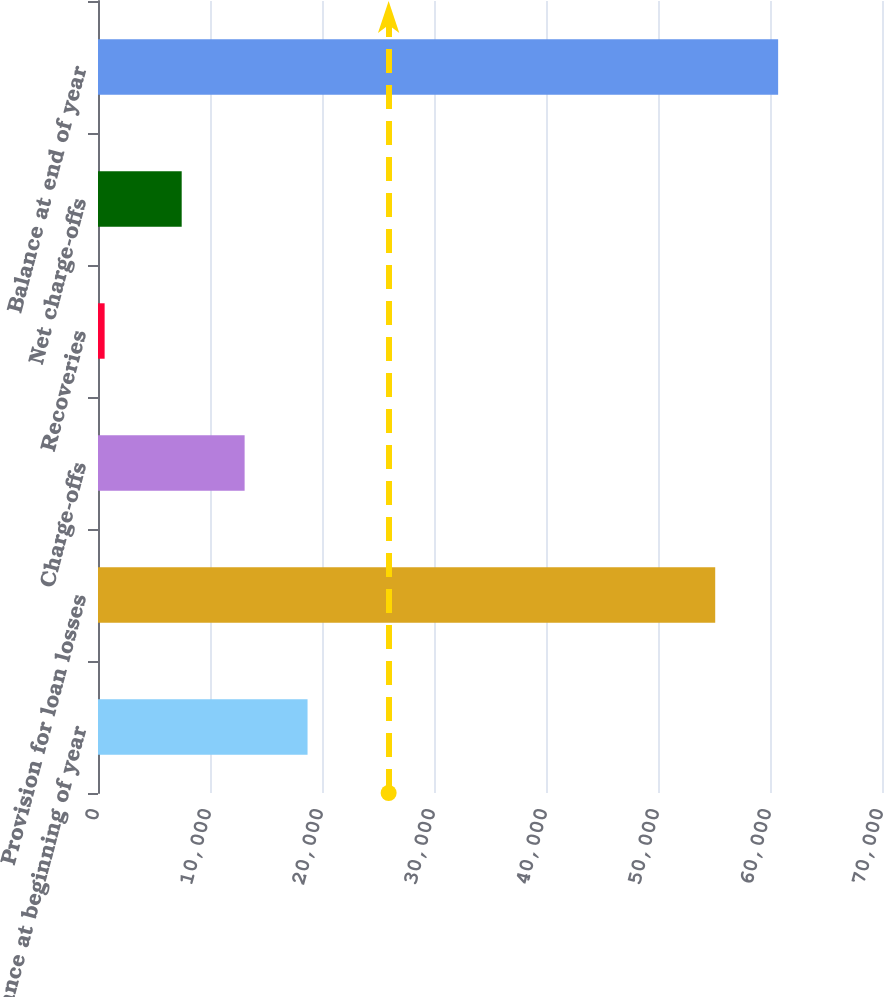<chart> <loc_0><loc_0><loc_500><loc_500><bar_chart><fcel>Balance at beginning of year<fcel>Provision for loan losses<fcel>Charge-offs<fcel>Recoveries<fcel>Net charge-offs<fcel>Balance at end of year<nl><fcel>18709.4<fcel>55108<fcel>13091.2<fcel>592<fcel>7473<fcel>60726.2<nl></chart> 